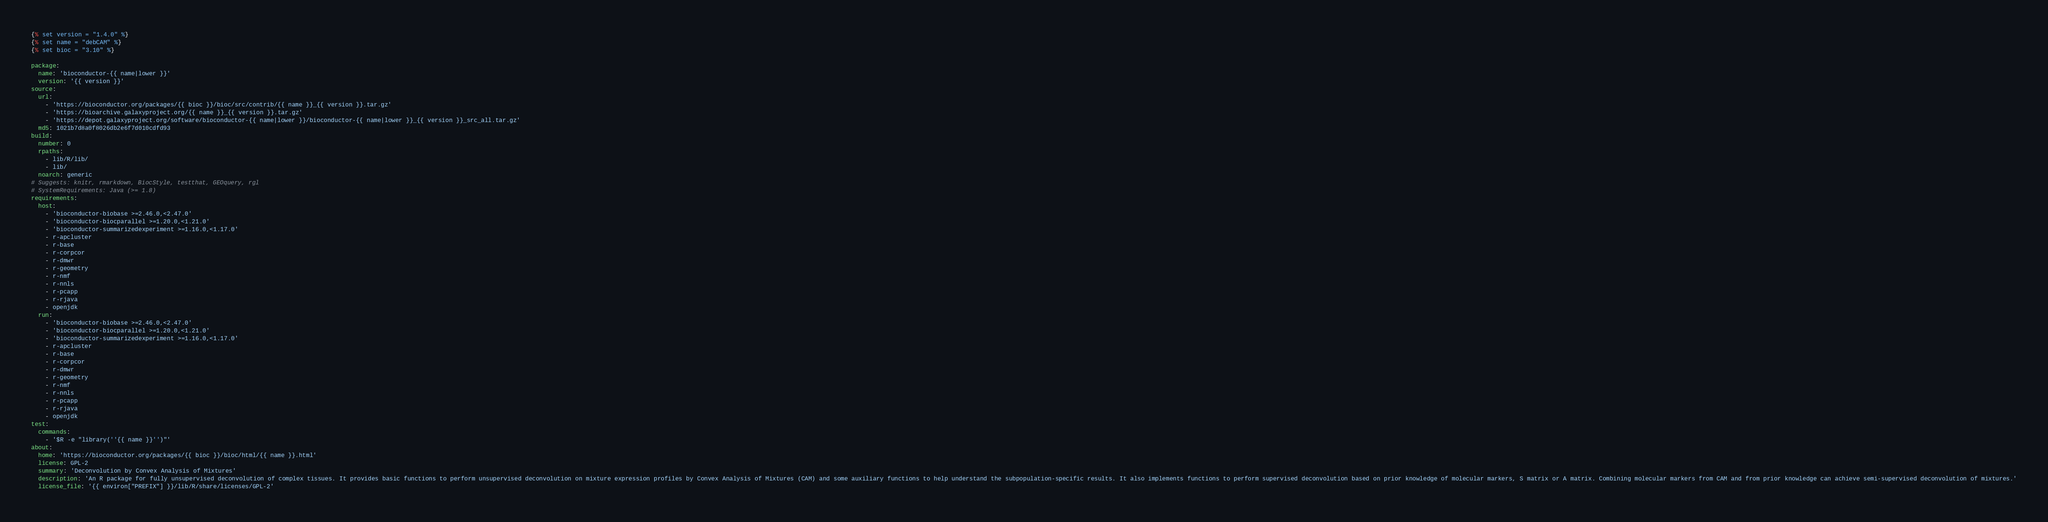Convert code to text. <code><loc_0><loc_0><loc_500><loc_500><_YAML_>{% set version = "1.4.0" %}
{% set name = "debCAM" %}
{% set bioc = "3.10" %}

package:
  name: 'bioconductor-{{ name|lower }}'
  version: '{{ version }}'
source:
  url:
    - 'https://bioconductor.org/packages/{{ bioc }}/bioc/src/contrib/{{ name }}_{{ version }}.tar.gz'
    - 'https://bioarchive.galaxyproject.org/{{ name }}_{{ version }}.tar.gz'
    - 'https://depot.galaxyproject.org/software/bioconductor-{{ name|lower }}/bioconductor-{{ name|lower }}_{{ version }}_src_all.tar.gz'
  md5: 1021b7d8a0f8026db2e6f7d010cdfd93
build:
  number: 0
  rpaths:
    - lib/R/lib/
    - lib/
  noarch: generic
# Suggests: knitr, rmarkdown, BiocStyle, testthat, GEOquery, rgl
# SystemRequirements: Java (>= 1.8)
requirements:
  host:
    - 'bioconductor-biobase >=2.46.0,<2.47.0'
    - 'bioconductor-biocparallel >=1.20.0,<1.21.0'
    - 'bioconductor-summarizedexperiment >=1.16.0,<1.17.0'
    - r-apcluster
    - r-base
    - r-corpcor
    - r-dmwr
    - r-geometry
    - r-nmf
    - r-nnls
    - r-pcapp
    - r-rjava
    - openjdk
  run:
    - 'bioconductor-biobase >=2.46.0,<2.47.0'
    - 'bioconductor-biocparallel >=1.20.0,<1.21.0'
    - 'bioconductor-summarizedexperiment >=1.16.0,<1.17.0'
    - r-apcluster
    - r-base
    - r-corpcor
    - r-dmwr
    - r-geometry
    - r-nmf
    - r-nnls
    - r-pcapp
    - r-rjava
    - openjdk
test:
  commands:
    - '$R -e "library(''{{ name }}'')"'
about:
  home: 'https://bioconductor.org/packages/{{ bioc }}/bioc/html/{{ name }}.html'
  license: GPL-2
  summary: 'Deconvolution by Convex Analysis of Mixtures'
  description: 'An R package for fully unsupervised deconvolution of complex tissues. It provides basic functions to perform unsupervised deconvolution on mixture expression profiles by Convex Analysis of Mixtures (CAM) and some auxiliary functions to help understand the subpopulation-specific results. It also implements functions to perform supervised deconvolution based on prior knowledge of molecular markers, S matrix or A matrix. Combining molecular markers from CAM and from prior knowledge can achieve semi-supervised deconvolution of mixtures.'
  license_file: '{{ environ["PREFIX"] }}/lib/R/share/licenses/GPL-2'

</code> 